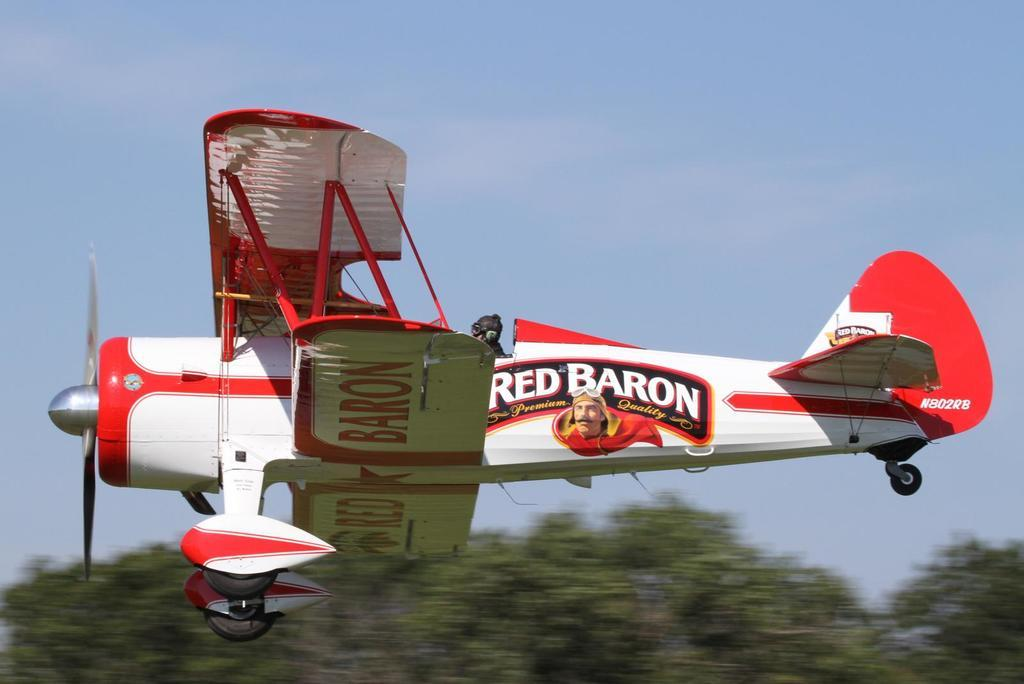What is the main subject of the picture? The main subject of the picture is an aircraft. What can be seen at the bottom of the picture? There are trees at the bottom of the picture. What is visible at the top of the picture? The sky is visible at the top of the picture. How many socks are hanging from the trees in the picture? There are no socks present in the image; it features an aircraft and trees. What type of dog can be seen interacting with the aircraft in the picture? There is no dog present in the image; it only features an aircraft and trees. 